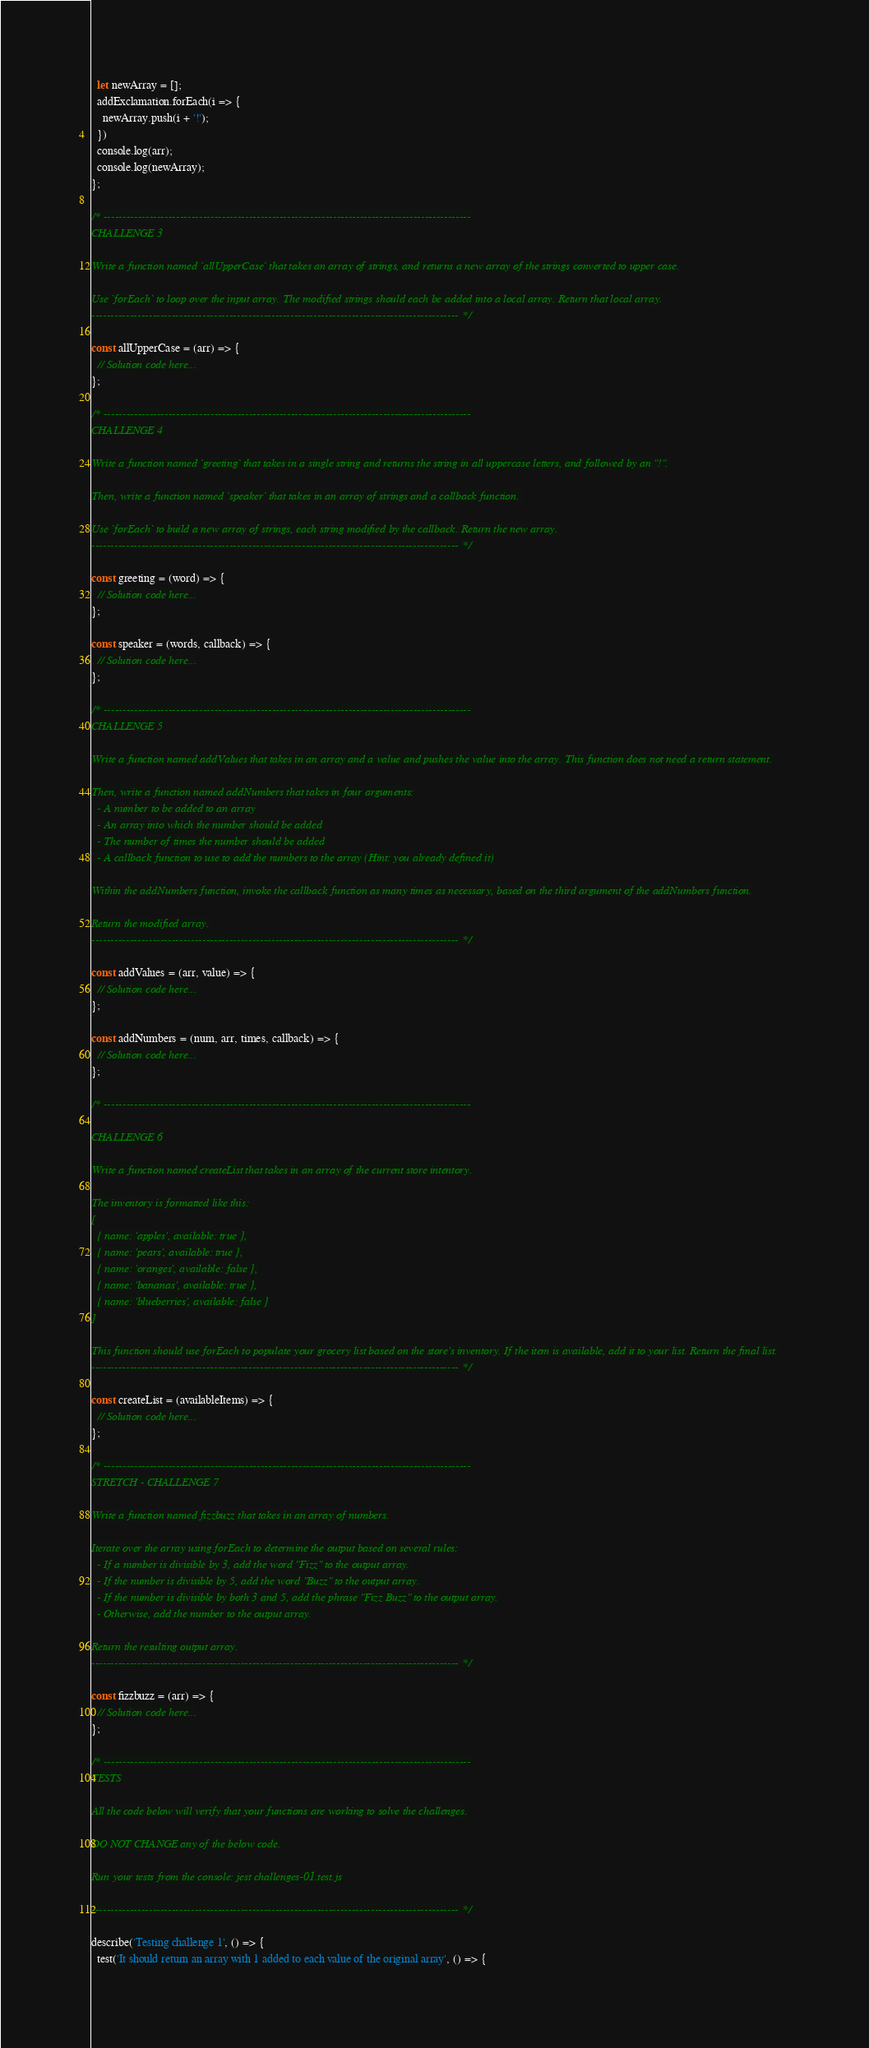<code> <loc_0><loc_0><loc_500><loc_500><_JavaScript_>  let newArray = [];
  addExclamation.forEach(i => {
    newArray.push(i + '!');
  })
  console.log(arr);
  console.log(newArray);
};

/* ------------------------------------------------------------------------------------------------
CHALLENGE 3

Write a function named `allUpperCase` that takes an array of strings, and returns a new array of the strings converted to upper case.

Use `forEach` to loop over the input array. The modified strings should each be added into a local array. Return that local array.
------------------------------------------------------------------------------------------------ */

const allUpperCase = (arr) => {
  // Solution code here...
};

/* ------------------------------------------------------------------------------------------------
CHALLENGE 4

Write a function named `greeting` that takes in a single string and returns the string in all uppercase letters, and followed by an "!".

Then, write a function named `speaker` that takes in an array of strings and a callback function. 

Use `forEach` to build a new array of strings, each string modified by the callback. Return the new array. 
------------------------------------------------------------------------------------------------ */

const greeting = (word) => {
  // Solution code here...
};

const speaker = (words, callback) => {
  // Solution code here...
};

/* ------------------------------------------------------------------------------------------------
CHALLENGE 5

Write a function named addValues that takes in an array and a value and pushes the value into the array. This function does not need a return statement.

Then, write a function named addNumbers that takes in four arguments:
  - A number to be added to an array
  - An array into which the number should be added
  - The number of times the number should be added
  - A callback function to use to add the numbers to the array (Hint: you already defined it)

Within the addNumbers function, invoke the callback function as many times as necessary, based on the third argument of the addNumbers function.

Return the modified array.
------------------------------------------------------------------------------------------------ */

const addValues = (arr, value) => {
  // Solution code here...
};

const addNumbers = (num, arr, times, callback) => {
  // Solution code here...
};

/* ------------------------------------------------------------------------------------------------

CHALLENGE 6

Write a function named createList that takes in an array of the current store intentory.

The inventory is formatted like this:
[
  { name: 'apples', available: true },
  { name: 'pears', available: true },
  { name: 'oranges', available: false },
  { name: 'bananas', available: true },
  { name: 'blueberries', available: false }
]

This function should use forEach to populate your grocery list based on the store's inventory. If the item is available, add it to your list. Return the final list.
------------------------------------------------------------------------------------------------ */

const createList = (availableItems) => {
  // Solution code here...
};

/* ------------------------------------------------------------------------------------------------
STRETCH - CHALLENGE 7

Write a function named fizzbuzz that takes in an array of numbers.

Iterate over the array using forEach to determine the output based on several rules:
  - If a number is divisible by 3, add the word "Fizz" to the output array.
  - If the number is divisible by 5, add the word "Buzz" to the output array.
  - If the number is divisible by both 3 and 5, add the phrase "Fizz Buzz" to the output array.
  - Otherwise, add the number to the output array.

Return the resulting output array.
------------------------------------------------------------------------------------------------ */

const fizzbuzz = (arr) => {
  // Solution code here...
};

/* ------------------------------------------------------------------------------------------------
TESTS

All the code below will verify that your functions are working to solve the challenges.

DO NOT CHANGE any of the below code.

Run your tests from the console: jest challenges-01.test.js

------------------------------------------------------------------------------------------------ */

describe('Testing challenge 1', () => {
  test('It should return an array with 1 added to each value of the original array', () => {</code> 